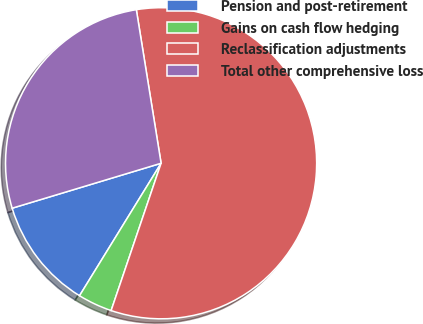<chart> <loc_0><loc_0><loc_500><loc_500><pie_chart><fcel>Pension and post-retirement<fcel>Gains on cash flow hedging<fcel>Reclassification adjustments<fcel>Total other comprehensive loss<nl><fcel>11.55%<fcel>3.58%<fcel>57.75%<fcel>27.12%<nl></chart> 